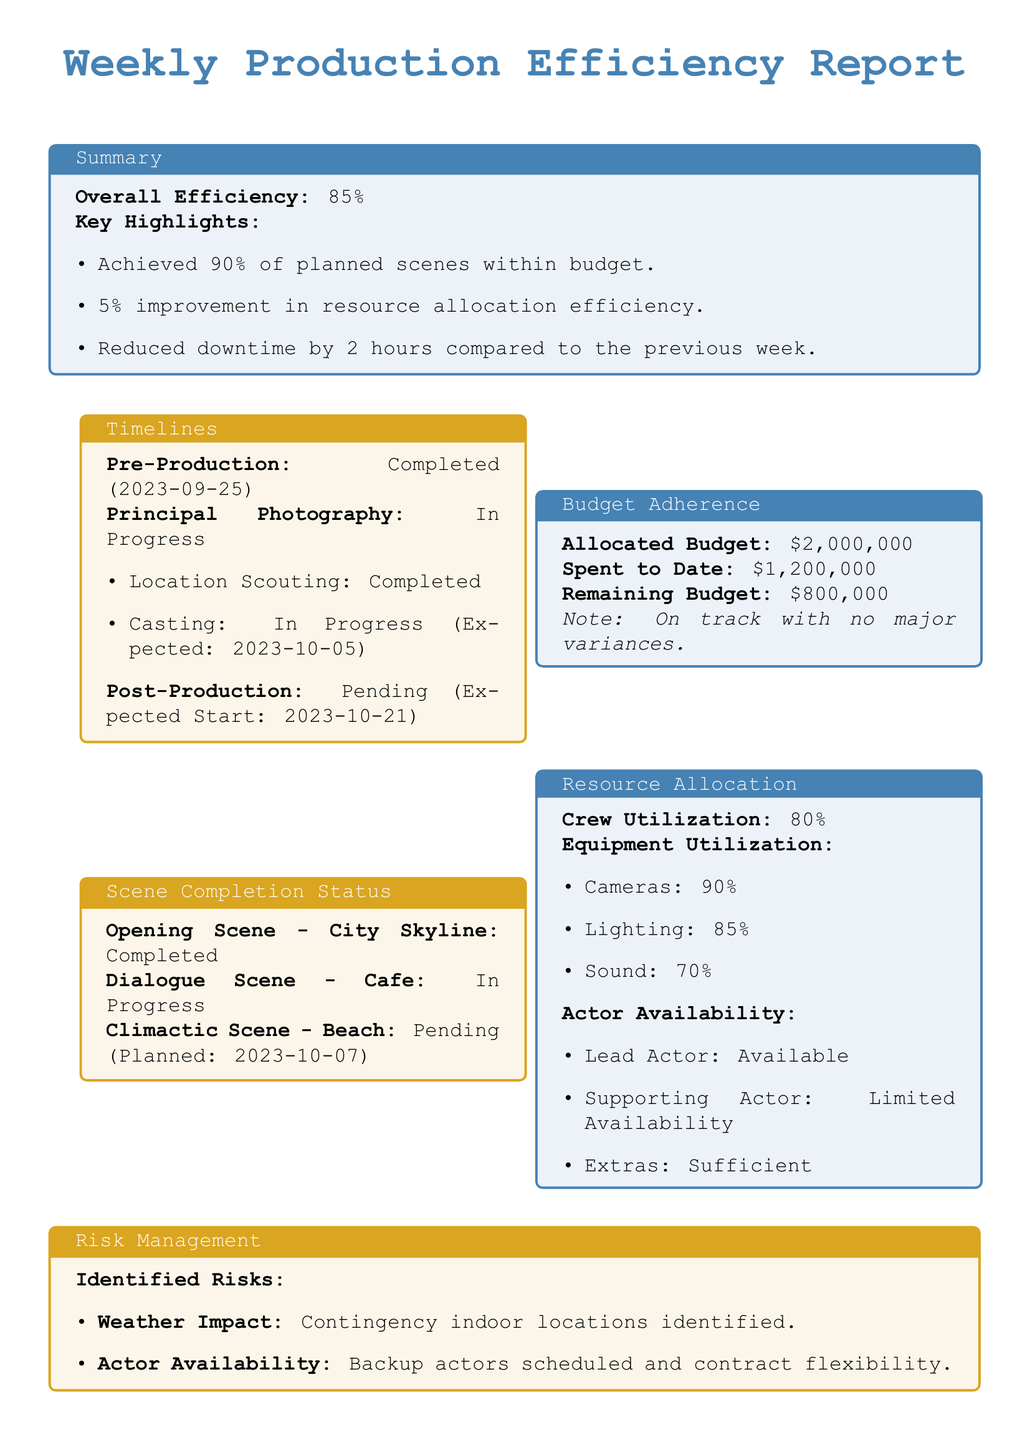what is the overall efficiency percentage? The overall efficiency percentage is stated in the summary section of the report.
Answer: 85% what is the allocated budget for the project? The allocated budget is mentioned in the budget adherence section of the report.
Answer: $2,000,000 how many scenes were completed within budget? The report indicates that 90% of planned scenes were achieved within budget.
Answer: 90% what is the remaining budget after expenditures? The remaining budget is calculated by subtracting the amount spent to date from the allocated budget.
Answer: $800,000 when is the casting expected to be completed? The timeline section specifies the expected completion date for casting.
Answer: 2023-10-05 what is the crew utilization percentage? The crew utilization percentage is detailed in the resource allocation section.
Answer: 80% what is the status of the climactic scene? The status of the climactic scene is provided in the scene completion status section.
Answer: Pending what is the identified risk related to weather? The identified risk regarding weather is noted in the risk management section of the report.
Answer: Weather Impact how many cameras are being utilized? The equipment utilization section lists the utilization percentage of cameras.
Answer: 90% what improvement in resource allocation efficiency was achieved? The report highlights a percentage increase in resource allocation efficiency.
Answer: 5% 